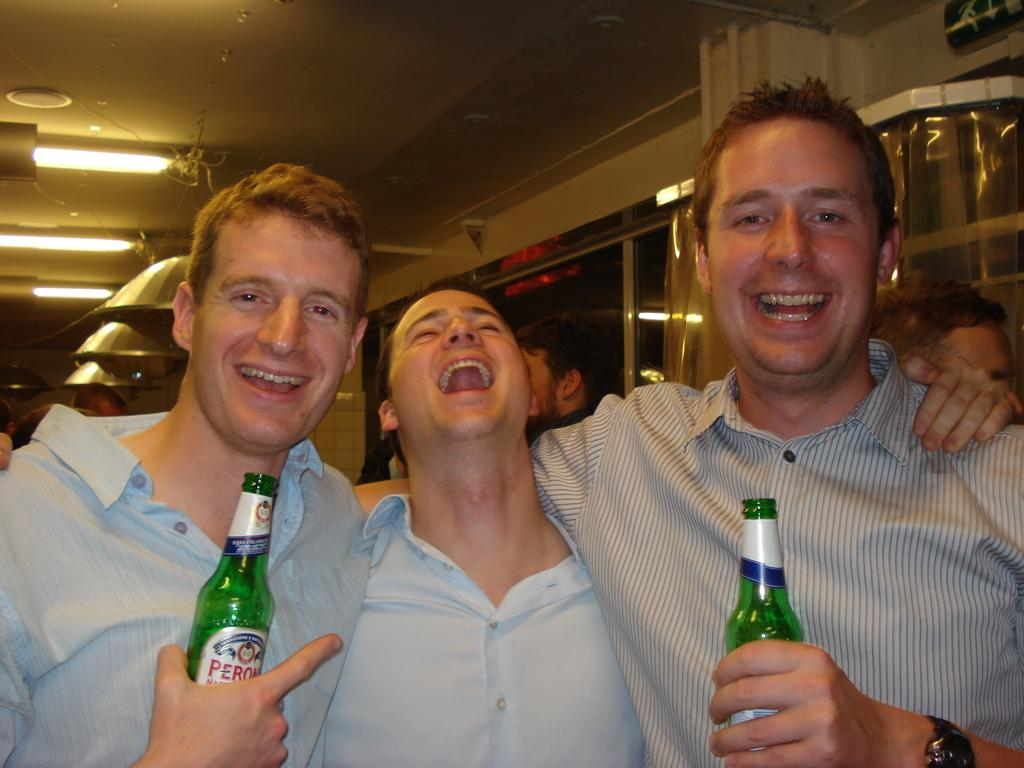Who or what is present in the image? There are people in the image. What are two of the people holding in their hands? Two of the people are holding bottles in their hands. How are the people feeling or expressing themselves in the image? The people have smiles on their faces, indicating that they are happy or enjoying themselves. What type of dogs can be seen playing with a jewel on the dock in the image? There are no dogs, jewels, or docks present in the image; it only features people holding bottles and smiling. 